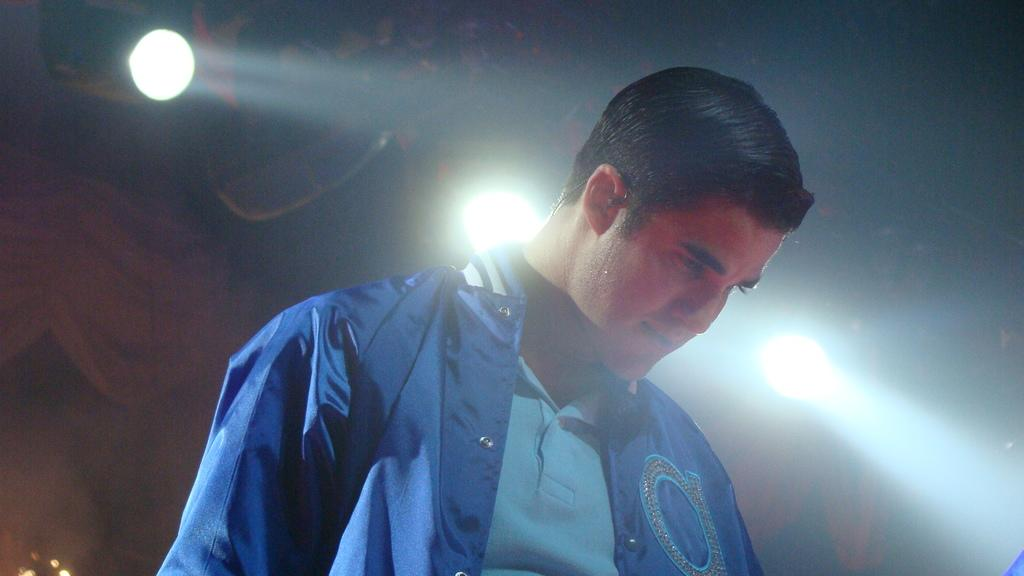Who is present in the image? There is a man in the image. What is the man wearing on his upper body? The man is wearing a blue coat and a t-shirt. Can you describe any lighting effects in the image? Yes, there are focused lights in the image. What type of skin is visible on the man's face in the image? There is no information about the man's skin in the image, so it cannot be determined from the provided facts. 